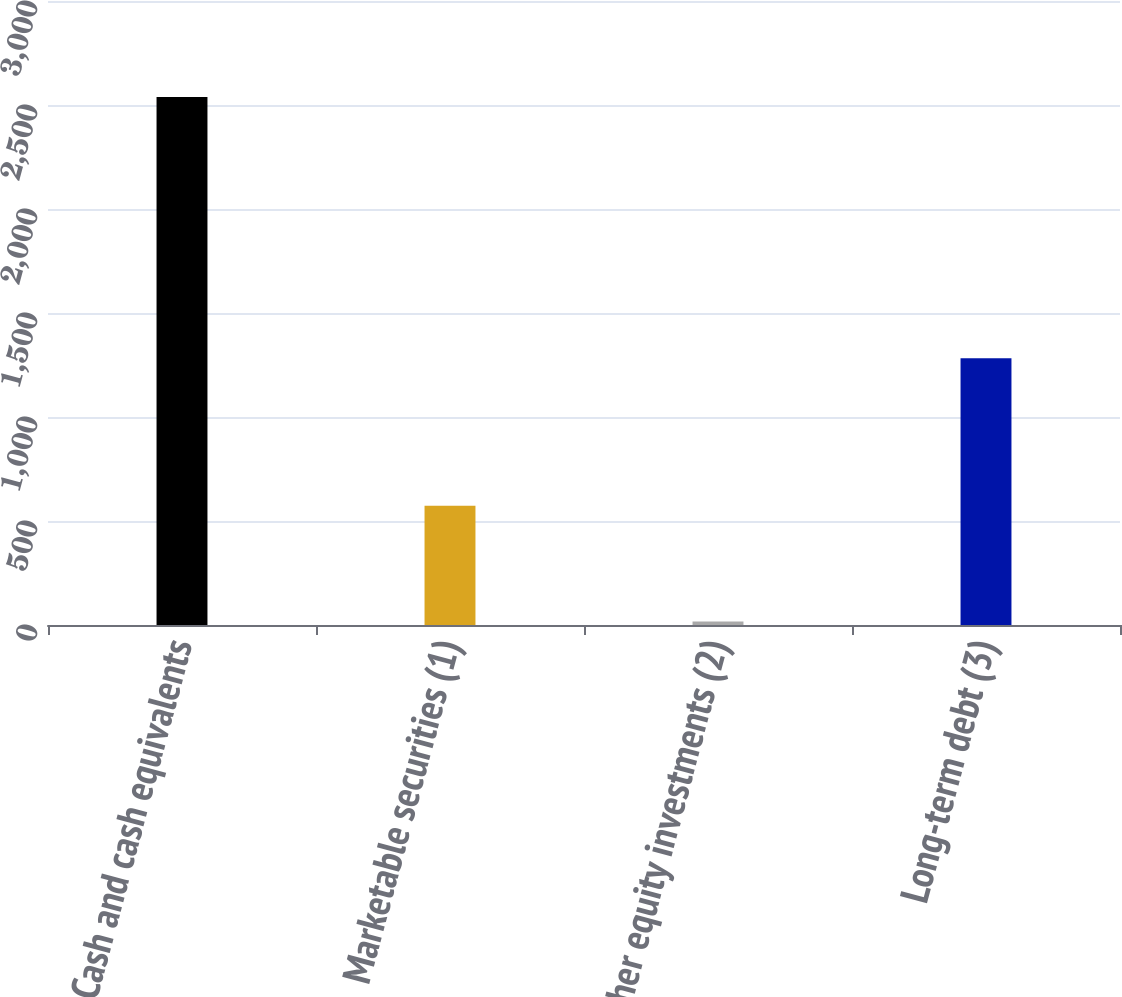<chart> <loc_0><loc_0><loc_500><loc_500><bar_chart><fcel>Cash and cash equivalents<fcel>Marketable securities (1)<fcel>Other equity investments (2)<fcel>Long-term debt (3)<nl><fcel>2539<fcel>573<fcel>17<fcel>1282<nl></chart> 